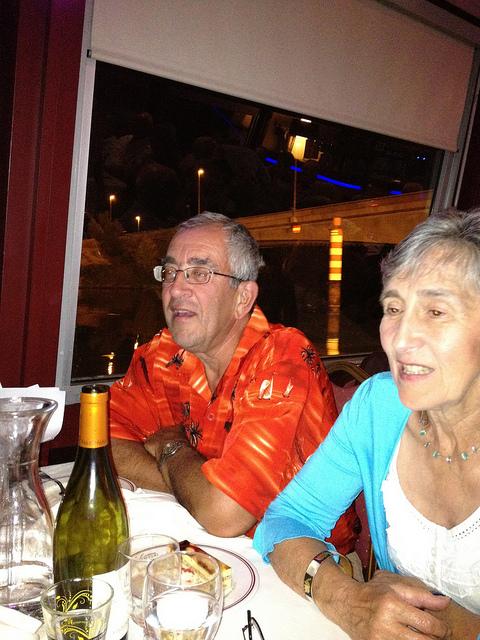Who is wearing glasses?
Short answer required. Man. Is there wine on the table?
Answer briefly. Yes. The man is young?
Concise answer only. No. 